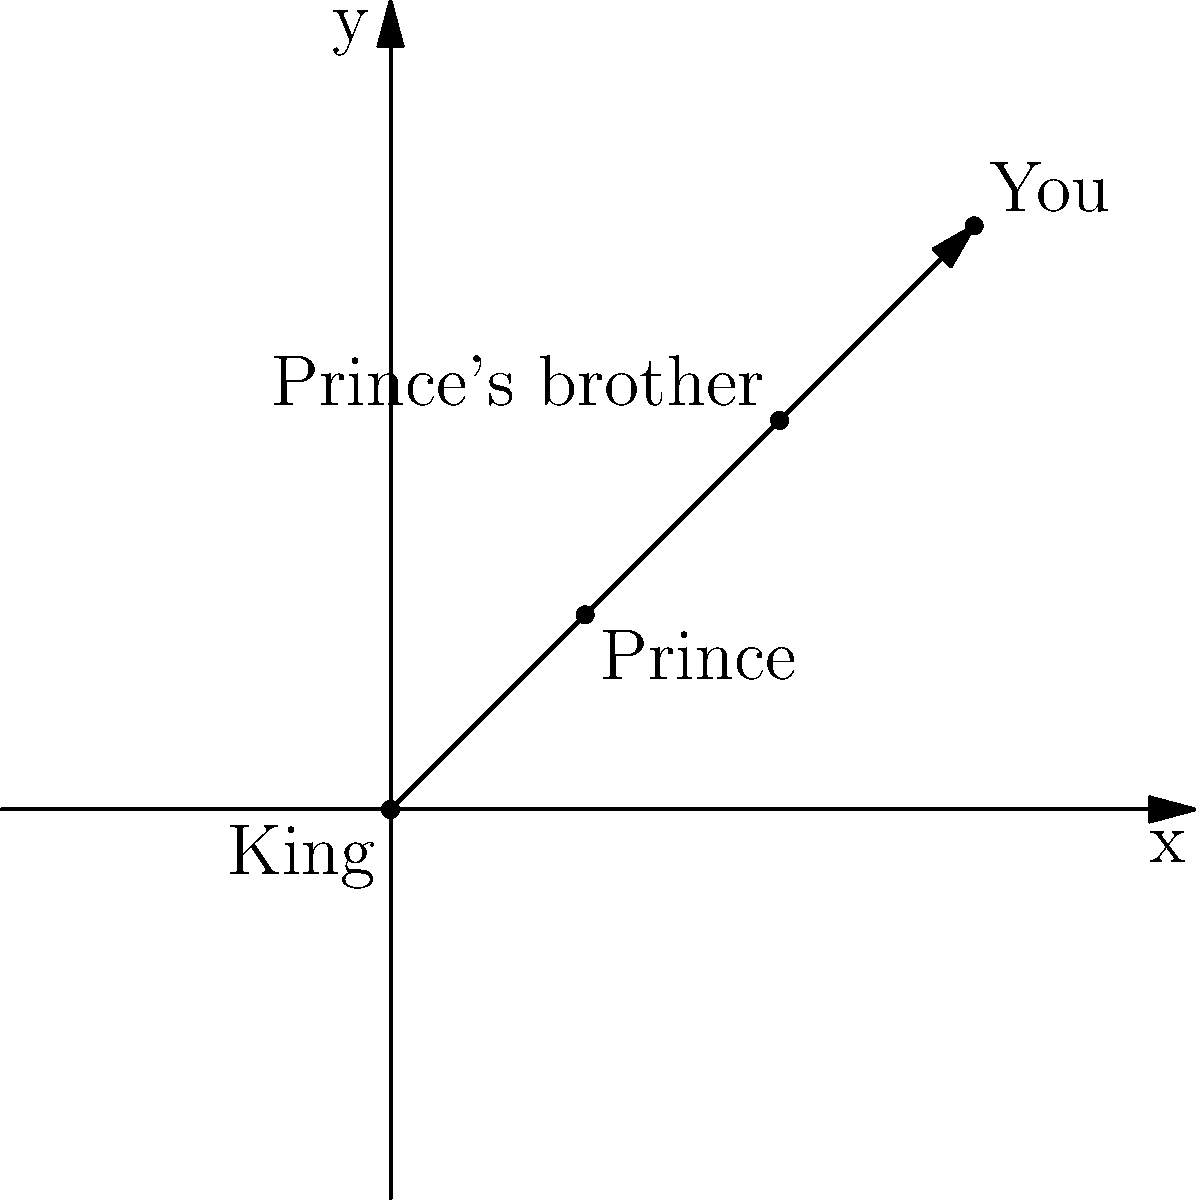In a royal family tree plotted on a 2D coordinate plane, the King is at (0,0), the Prince at (1,1), and the Prince's brother at (2,2). If each generation is represented by a unit increase in both x and y coordinates, where would you, as the great-grandchild of the Prince's brother, be located? Let's approach this step-by-step:

1) We start with the King at (0,0).
2) The Prince, being one generation away, is at (1,1).
3) The Prince's brother, being in the same generation as the Prince, is at (2,2).
4) Now, we need to move three generations from the Prince's brother to reach you:
   - Your grandparent (child of the Prince's brother) would be at (3,3)
   - Your parent would be at (4,4)
   - You, as the great-grandchild, would be at (5,5)

5) Each generation moves one unit in both x and y directions, following the pattern established in the given information.

Therefore, your position as the great-grandchild of the Prince's brother would be at (5,5) on this coordinate plane.
Answer: (5,5) 